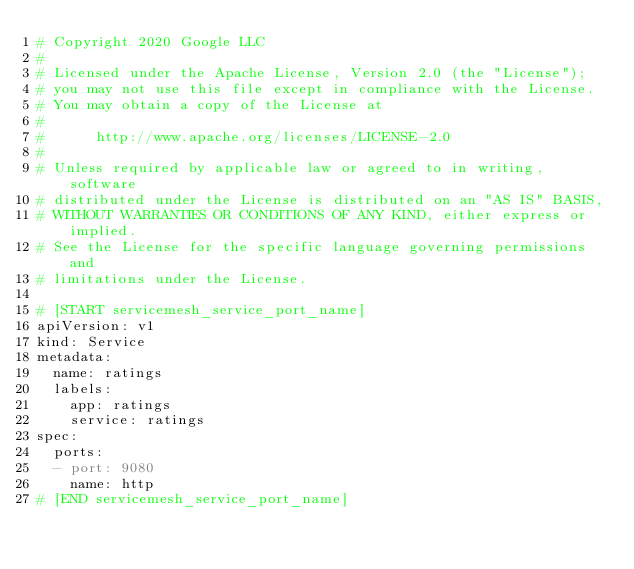Convert code to text. <code><loc_0><loc_0><loc_500><loc_500><_YAML_># Copyright 2020 Google LLC
#
# Licensed under the Apache License, Version 2.0 (the "License");
# you may not use this file except in compliance with the License.
# You may obtain a copy of the License at
#
#      http://www.apache.org/licenses/LICENSE-2.0
#
# Unless required by applicable law or agreed to in writing, software
# distributed under the License is distributed on an "AS IS" BASIS,
# WITHOUT WARRANTIES OR CONDITIONS OF ANY KIND, either express or implied.
# See the License for the specific language governing permissions and
# limitations under the License.

# [START servicemesh_service_port_name]
apiVersion: v1
kind: Service
metadata:
  name: ratings
  labels:
    app: ratings
    service: ratings
spec:
  ports:
  - port: 9080
    name: http
# [END servicemesh_service_port_name]
</code> 